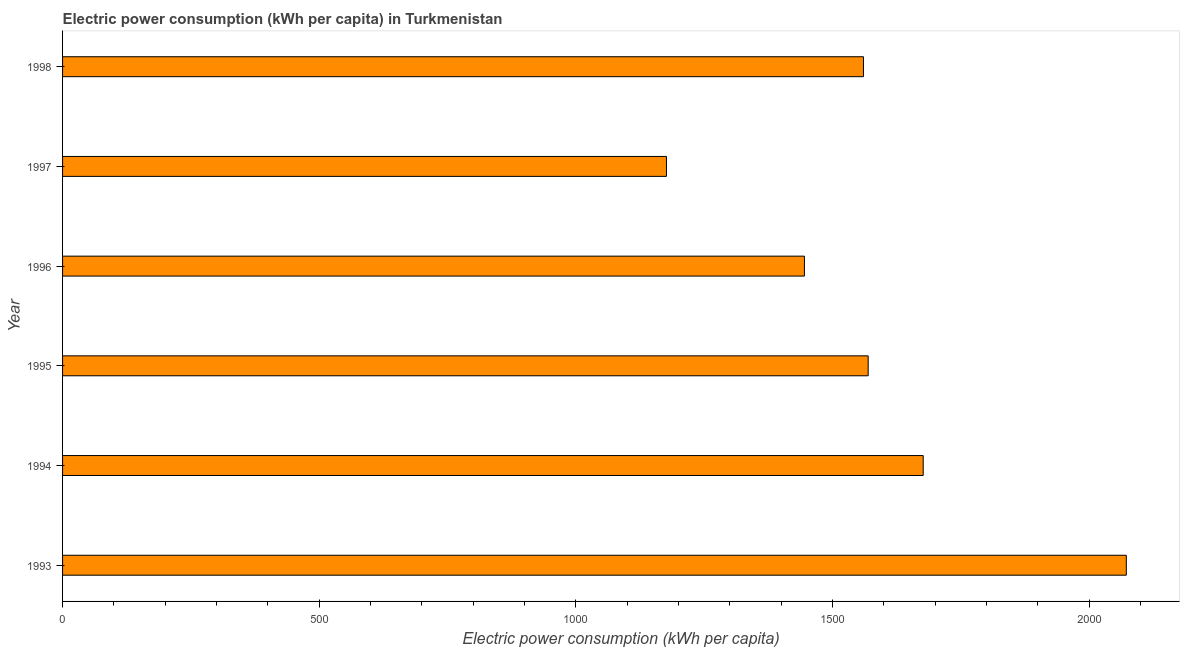Does the graph contain grids?
Provide a succinct answer. No. What is the title of the graph?
Ensure brevity in your answer.  Electric power consumption (kWh per capita) in Turkmenistan. What is the label or title of the X-axis?
Your answer should be very brief. Electric power consumption (kWh per capita). What is the electric power consumption in 1996?
Offer a very short reply. 1445.51. Across all years, what is the maximum electric power consumption?
Offer a terse response. 2072.69. Across all years, what is the minimum electric power consumption?
Your answer should be very brief. 1176.66. In which year was the electric power consumption minimum?
Provide a short and direct response. 1997. What is the sum of the electric power consumption?
Offer a very short reply. 9502.07. What is the difference between the electric power consumption in 1994 and 1998?
Your answer should be very brief. 116.42. What is the average electric power consumption per year?
Keep it short and to the point. 1583.68. What is the median electric power consumption?
Give a very brief answer. 1565.13. Do a majority of the years between 1998 and 1994 (inclusive) have electric power consumption greater than 100 kWh per capita?
Your answer should be compact. Yes. What is the ratio of the electric power consumption in 1993 to that in 1995?
Provide a short and direct response. 1.32. What is the difference between the highest and the second highest electric power consumption?
Make the answer very short. 395.73. Is the sum of the electric power consumption in 1994 and 1998 greater than the maximum electric power consumption across all years?
Ensure brevity in your answer.  Yes. What is the difference between the highest and the lowest electric power consumption?
Provide a succinct answer. 896.03. In how many years, is the electric power consumption greater than the average electric power consumption taken over all years?
Keep it short and to the point. 2. How many bars are there?
Ensure brevity in your answer.  6. Are all the bars in the graph horizontal?
Provide a short and direct response. Yes. How many years are there in the graph?
Give a very brief answer. 6. What is the difference between two consecutive major ticks on the X-axis?
Your response must be concise. 500. Are the values on the major ticks of X-axis written in scientific E-notation?
Offer a very short reply. No. What is the Electric power consumption (kWh per capita) in 1993?
Make the answer very short. 2072.69. What is the Electric power consumption (kWh per capita) in 1994?
Your answer should be compact. 1676.96. What is the Electric power consumption (kWh per capita) in 1995?
Make the answer very short. 1569.72. What is the Electric power consumption (kWh per capita) in 1996?
Give a very brief answer. 1445.51. What is the Electric power consumption (kWh per capita) of 1997?
Offer a very short reply. 1176.66. What is the Electric power consumption (kWh per capita) of 1998?
Offer a very short reply. 1560.53. What is the difference between the Electric power consumption (kWh per capita) in 1993 and 1994?
Make the answer very short. 395.73. What is the difference between the Electric power consumption (kWh per capita) in 1993 and 1995?
Keep it short and to the point. 502.97. What is the difference between the Electric power consumption (kWh per capita) in 1993 and 1996?
Your answer should be compact. 627.18. What is the difference between the Electric power consumption (kWh per capita) in 1993 and 1997?
Make the answer very short. 896.03. What is the difference between the Electric power consumption (kWh per capita) in 1993 and 1998?
Provide a succinct answer. 512.16. What is the difference between the Electric power consumption (kWh per capita) in 1994 and 1995?
Your answer should be very brief. 107.24. What is the difference between the Electric power consumption (kWh per capita) in 1994 and 1996?
Ensure brevity in your answer.  231.44. What is the difference between the Electric power consumption (kWh per capita) in 1994 and 1997?
Your answer should be compact. 500.29. What is the difference between the Electric power consumption (kWh per capita) in 1994 and 1998?
Provide a short and direct response. 116.42. What is the difference between the Electric power consumption (kWh per capita) in 1995 and 1996?
Keep it short and to the point. 124.21. What is the difference between the Electric power consumption (kWh per capita) in 1995 and 1997?
Provide a succinct answer. 393.06. What is the difference between the Electric power consumption (kWh per capita) in 1995 and 1998?
Your answer should be compact. 9.19. What is the difference between the Electric power consumption (kWh per capita) in 1996 and 1997?
Offer a very short reply. 268.85. What is the difference between the Electric power consumption (kWh per capita) in 1996 and 1998?
Provide a succinct answer. -115.02. What is the difference between the Electric power consumption (kWh per capita) in 1997 and 1998?
Keep it short and to the point. -383.87. What is the ratio of the Electric power consumption (kWh per capita) in 1993 to that in 1994?
Your response must be concise. 1.24. What is the ratio of the Electric power consumption (kWh per capita) in 1993 to that in 1995?
Your answer should be compact. 1.32. What is the ratio of the Electric power consumption (kWh per capita) in 1993 to that in 1996?
Provide a succinct answer. 1.43. What is the ratio of the Electric power consumption (kWh per capita) in 1993 to that in 1997?
Offer a very short reply. 1.76. What is the ratio of the Electric power consumption (kWh per capita) in 1993 to that in 1998?
Keep it short and to the point. 1.33. What is the ratio of the Electric power consumption (kWh per capita) in 1994 to that in 1995?
Your answer should be very brief. 1.07. What is the ratio of the Electric power consumption (kWh per capita) in 1994 to that in 1996?
Your response must be concise. 1.16. What is the ratio of the Electric power consumption (kWh per capita) in 1994 to that in 1997?
Give a very brief answer. 1.43. What is the ratio of the Electric power consumption (kWh per capita) in 1994 to that in 1998?
Make the answer very short. 1.07. What is the ratio of the Electric power consumption (kWh per capita) in 1995 to that in 1996?
Give a very brief answer. 1.09. What is the ratio of the Electric power consumption (kWh per capita) in 1995 to that in 1997?
Your response must be concise. 1.33. What is the ratio of the Electric power consumption (kWh per capita) in 1996 to that in 1997?
Offer a terse response. 1.23. What is the ratio of the Electric power consumption (kWh per capita) in 1996 to that in 1998?
Your answer should be very brief. 0.93. What is the ratio of the Electric power consumption (kWh per capita) in 1997 to that in 1998?
Make the answer very short. 0.75. 